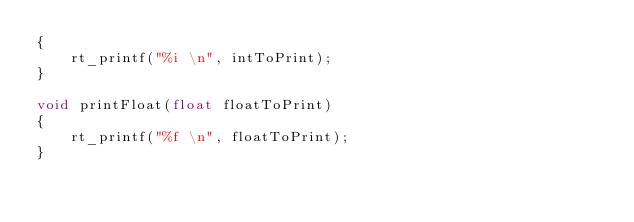<code> <loc_0><loc_0><loc_500><loc_500><_C_>{
	rt_printf("%i \n", intToPrint);
}

void printFloat(float floatToPrint)
{
	rt_printf("%f \n", floatToPrint);
}</code> 